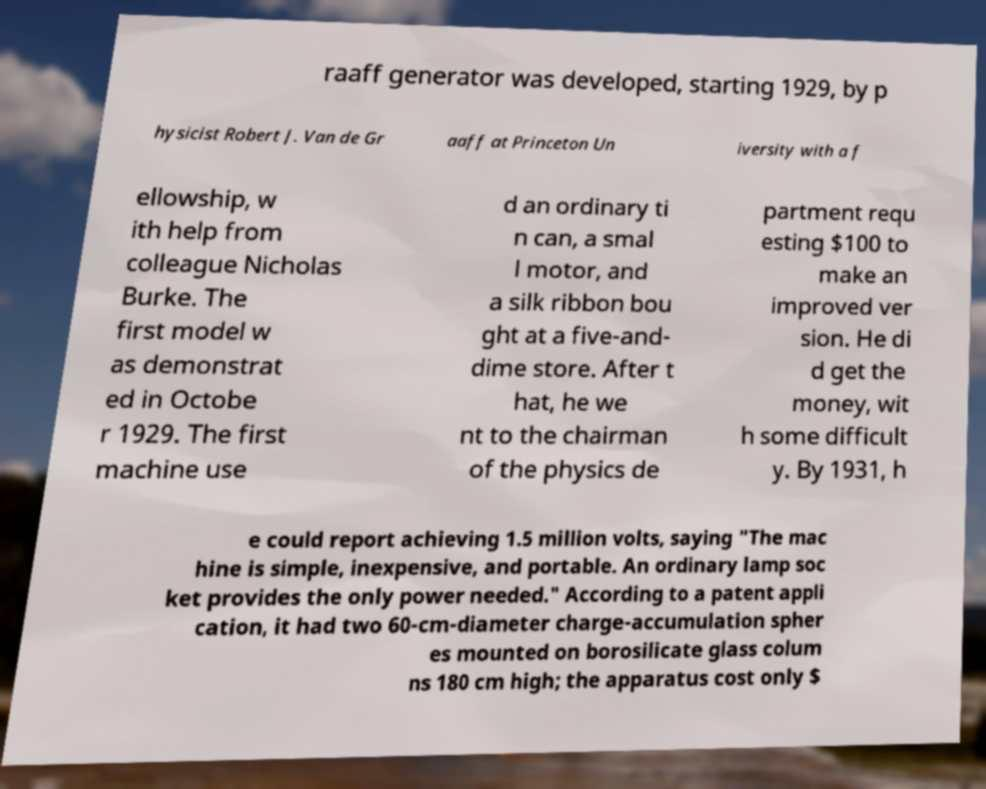Please identify and transcribe the text found in this image. raaff generator was developed, starting 1929, by p hysicist Robert J. Van de Gr aaff at Princeton Un iversity with a f ellowship, w ith help from colleague Nicholas Burke. The first model w as demonstrat ed in Octobe r 1929. The first machine use d an ordinary ti n can, a smal l motor, and a silk ribbon bou ght at a five-and- dime store. After t hat, he we nt to the chairman of the physics de partment requ esting $100 to make an improved ver sion. He di d get the money, wit h some difficult y. By 1931, h e could report achieving 1.5 million volts, saying "The mac hine is simple, inexpensive, and portable. An ordinary lamp soc ket provides the only power needed." According to a patent appli cation, it had two 60-cm-diameter charge-accumulation spher es mounted on borosilicate glass colum ns 180 cm high; the apparatus cost only $ 